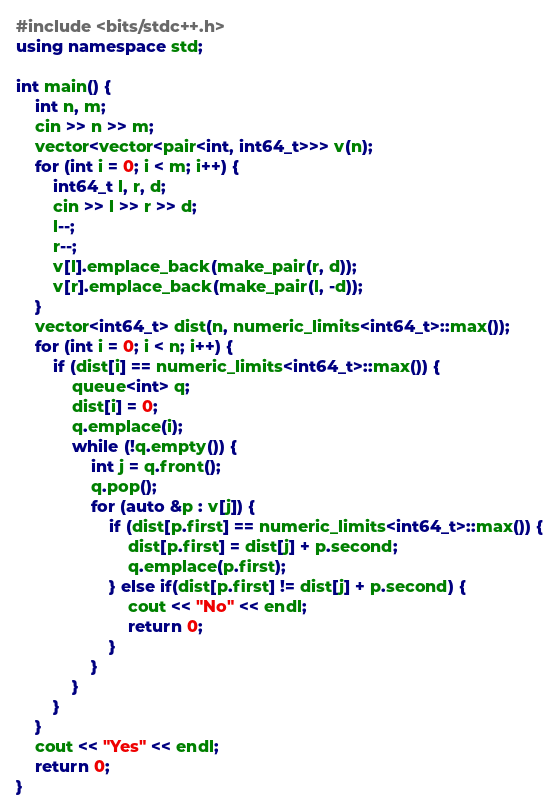<code> <loc_0><loc_0><loc_500><loc_500><_C++_>#include <bits/stdc++.h>
using namespace std;

int main() {
	int n, m;
	cin >> n >> m;
	vector<vector<pair<int, int64_t>>> v(n);
	for (int i = 0; i < m; i++) {
		int64_t l, r, d;
		cin >> l >> r >> d;
		l--;
		r--;
		v[l].emplace_back(make_pair(r, d));
		v[r].emplace_back(make_pair(l, -d));
	}
	vector<int64_t> dist(n, numeric_limits<int64_t>::max());
	for (int i = 0; i < n; i++) {
		if (dist[i] == numeric_limits<int64_t>::max()) {
			queue<int> q;
			dist[i] = 0;
			q.emplace(i);
			while (!q.empty()) {
				int j = q.front();
				q.pop();
				for (auto &p : v[j]) {
					if (dist[p.first] == numeric_limits<int64_t>::max()) {
						dist[p.first] = dist[j] + p.second;
						q.emplace(p.first);
					} else if(dist[p.first] != dist[j] + p.second) {
						cout << "No" << endl;
						return 0;
					}
				}
			}
		}
	}
	cout << "Yes" << endl;
	return 0;
}</code> 